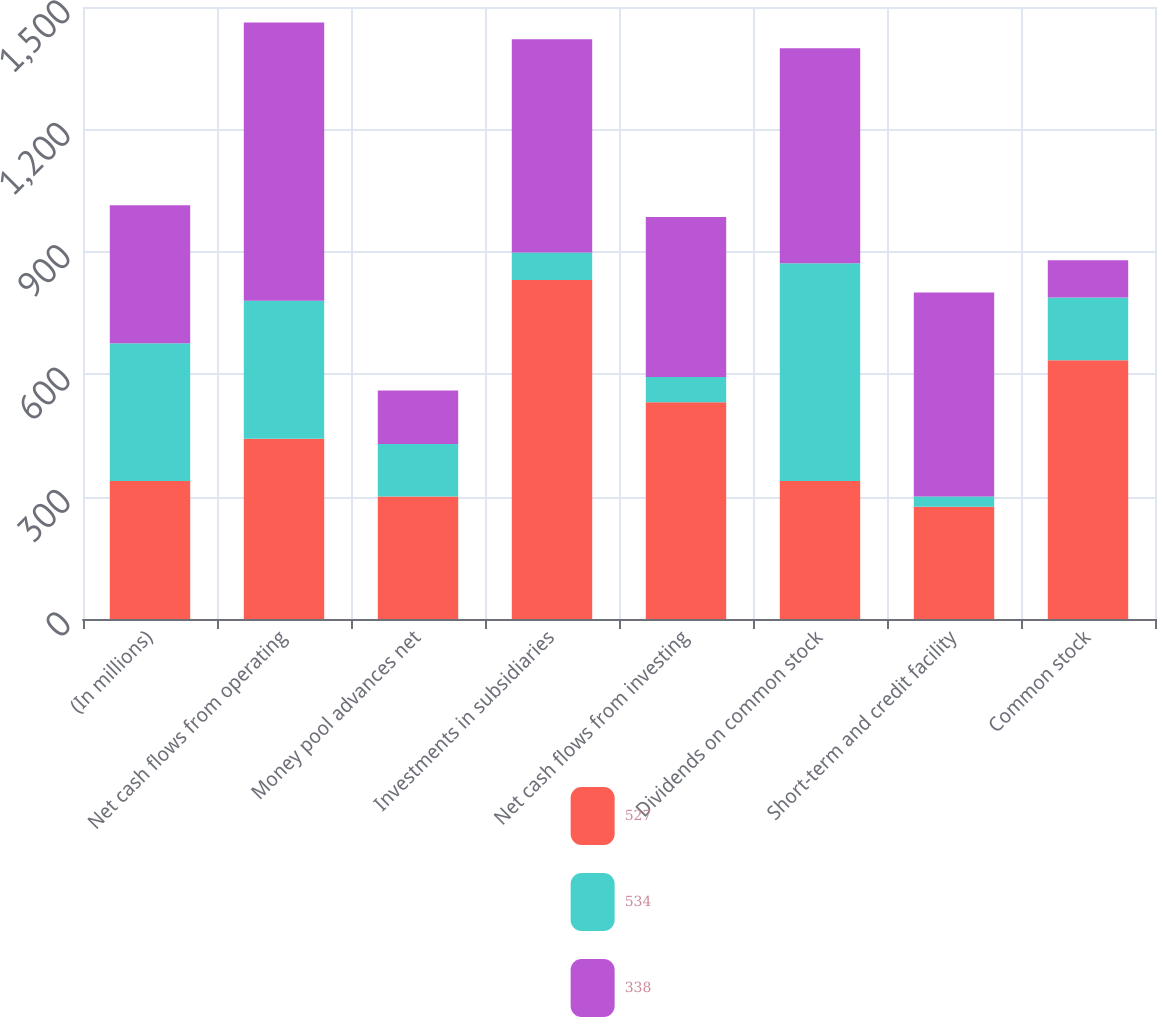<chart> <loc_0><loc_0><loc_500><loc_500><stacked_bar_chart><ecel><fcel>(In millions)<fcel>Net cash flows from operating<fcel>Money pool advances net<fcel>Investments in subsidiaries<fcel>Net cash flows from investing<fcel>Dividends on common stock<fcel>Short-term and credit facility<fcel>Common stock<nl><fcel>527<fcel>338<fcel>442<fcel>300<fcel>831<fcel>531<fcel>338<fcel>275<fcel>634<nl><fcel>534<fcel>338<fcel>338<fcel>129<fcel>67<fcel>62<fcel>534<fcel>25<fcel>154<nl><fcel>338<fcel>338<fcel>682<fcel>131<fcel>523<fcel>392<fcel>527<fcel>500<fcel>91<nl></chart> 